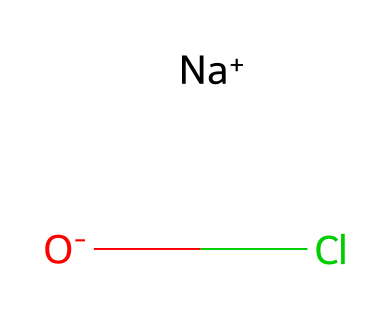What is the molecular formula of sodium hypochlorite? The SMILES representation shows sodium (Na), oxygen (O), and chlorine (Cl), which translates to the molecular formula NaClO, combining these elements based on their presence in the structure.
Answer: NaClO How many oxygen atoms are present in sodium hypochlorite? From the SMILES, there is one 'O' indicating that there is a single oxygen atom in the molecule.
Answer: 1 What type of bond is present between sodium and chlorine in this compound? Sodium (Na) and chlorine (Cl) form an ionic bond, as seen by the charge separation (Na+ and Cl-), which indicates that sodium donates an electron to chlorine.
Answer: ionic What is the charge of the sodium ion in sodium hypochlorite? The SMILES notation indicates that sodium (Na) has a positive charge (Na+), thus the charge of the sodium ion is positive one.
Answer: positive one What does the presence of the chlorine atom indicate about sodium hypochlorite? Chlorine, in this compound, contributes to the bleach properties due to its ability to interact with organic materials and bacteria, thus indicating its role as a disinfectant.
Answer: disinfectant Which part of the structure indicates that sodium hypochlorite is a hazardous chemical? The presence of chlorine (Cl) in the structure is associated with its reactivity and potential health risks, making sodium hypochlorite classified as hazardous.
Answer: chlorine 